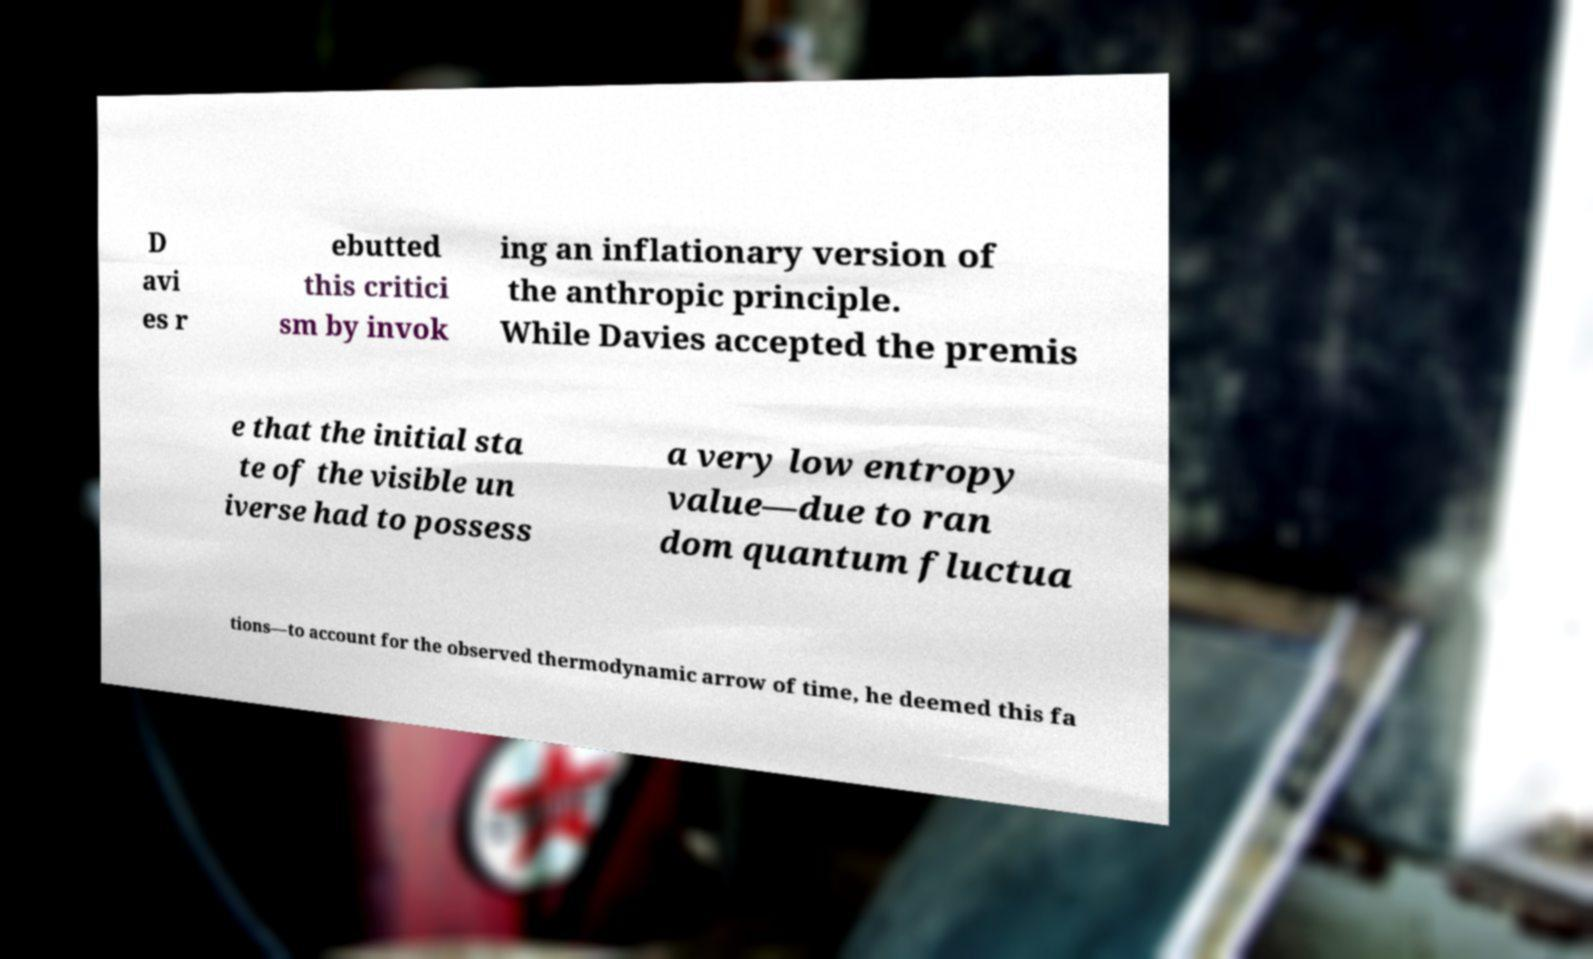Could you extract and type out the text from this image? D avi es r ebutted this critici sm by invok ing an inflationary version of the anthropic principle. While Davies accepted the premis e that the initial sta te of the visible un iverse had to possess a very low entropy value—due to ran dom quantum fluctua tions—to account for the observed thermodynamic arrow of time, he deemed this fa 